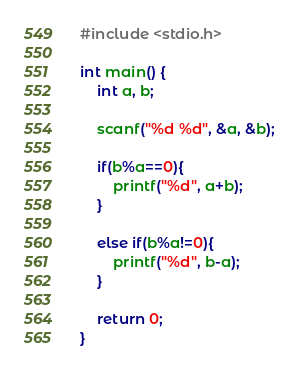<code> <loc_0><loc_0><loc_500><loc_500><_C_>#include <stdio.h>

int main() {
	int a, b;
	
	scanf("%d %d", &a, &b);
	
	if(b%a==0){
		printf("%d", a+b);
	}
	
	else if(b%a!=0){
		printf("%d", b-a);
	}
	
	return 0;
}</code> 